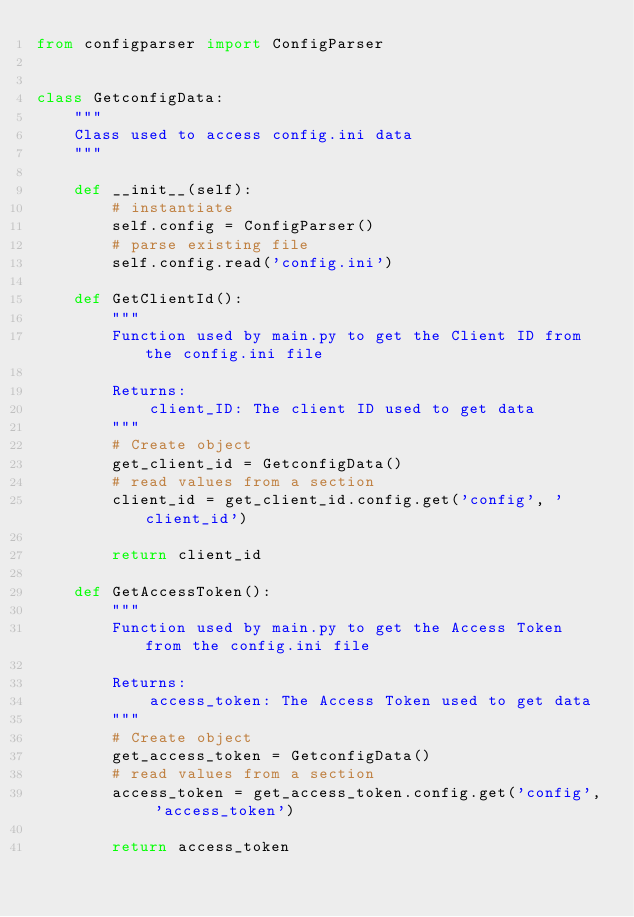<code> <loc_0><loc_0><loc_500><loc_500><_Python_>from configparser import ConfigParser


class GetconfigData:
    """
    Class used to access config.ini data
    """

    def __init__(self):
        # instantiate
        self.config = ConfigParser()
        # parse existing file
        self.config.read('config.ini')

    def GetClientId():
        """
        Function used by main.py to get the Client ID from the config.ini file

        Returns:
            client_ID: The client ID used to get data 
        """
        # Create object
        get_client_id = GetconfigData()
        # read values from a section
        client_id = get_client_id.config.get('config', 'client_id')

        return client_id

    def GetAccessToken():
        """
        Function used by main.py to get the Access Token from the config.ini file

        Returns:
            access_token: The Access Token used to get data 
        """
        # Create object
        get_access_token = GetconfigData()
        # read values from a section
        access_token = get_access_token.config.get('config', 'access_token')

        return access_token
</code> 